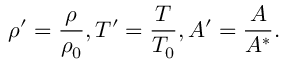Convert formula to latex. <formula><loc_0><loc_0><loc_500><loc_500>\rho ^ { \prime } = \frac { \rho } { \rho _ { 0 } } , T ^ { \prime } = \frac { T } { T _ { 0 } } , A ^ { \prime } = \frac { A } { A ^ { * } } .</formula> 